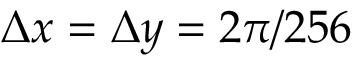Convert formula to latex. <formula><loc_0><loc_0><loc_500><loc_500>\Delta x = \Delta y = 2 \pi / 2 5 6</formula> 